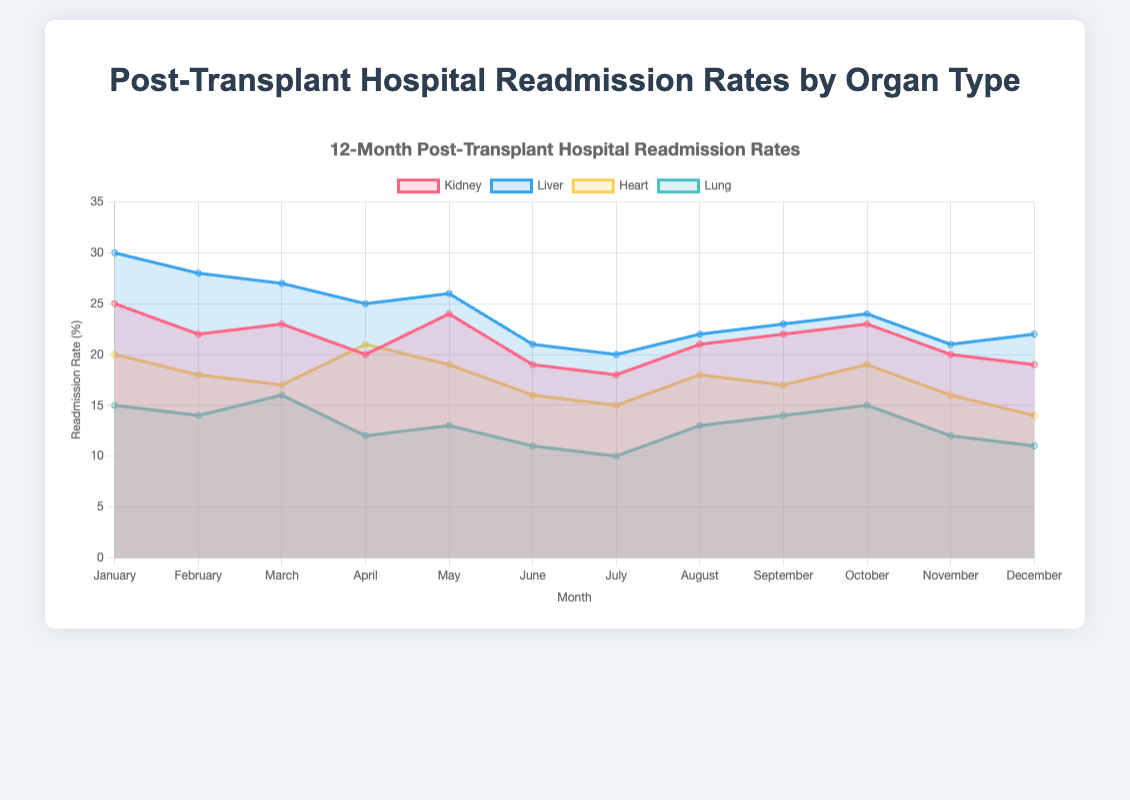How does the readmission rate for kidney transplants change from January to December? Notice that the readmission rate for kidney transplants starts at 25% in January and ends at 19% in December. The rate fluctuates within these months but has an overall decreasing trend.
Answer: Decreases Which organ type has the highest readmission rate in April? Look at the values for each organ type in April. Kidney has 20%, liver has 25%, heart has 21%, and lung has 12%. The liver has the highest readmission rate in April.
Answer: Liver What is the average readmission rate for lungs over the 12 months? Sum the readmission rates for lungs across all months: 15 + 14 + 16 + 12 + 13 + 11 + 10 + 13 + 14 + 15 + 12 + 11 = 156. Divide this by 12 to find the average: 156 / 12 = 13
Answer: 13 Compare the readmission rates for liver and heart transplants in June. Which one is higher? In June, liver transplants have a readmission rate of 21%, and heart transplants have a readmission rate of 16%. Thus, the liver readmission rate is higher.
Answer: Liver In which month is the readmission rate for heart transplants the lowest, and what is that rate? Review the heart transplant readmission rates across all months: January (20), February (18), March (17), April (21), May (19), June (16), July (15), August (18), September (17), October (19), November (16), and December (14). The lowest rate is in December at 14%.
Answer: December, 14% What is the total number of data points displayed for kidney transplants? A year's worth of monthly data is provided for kidney transplants. Therefore, there are 12 data points, one for each month.
Answer: 12 Between which months does the readmission rate for liver transplants show the largest increase? Observe the liver readmission rates for all months and identify the largest month-over-month increase. The largest increase occurs from June (21%) to July (20%), with an increase of 1%.
Answer: June to July How do the readmission rates for lung transplants in January compare to those in July? The readmission rate for lung transplants in January is 15%, while in July it is 10%. There is a decrease when comparing January to July.
Answer: Decrease What's the combined readmission rate for liver and kidney transplants in March? Add the readmission rates for liver and kidney in March: liver (27%) + kidney (23%) = 50%.
Answer: 50% What is the month-over-month change in readmission rate for heart transplants from October to November? The readmission rate for heart transplants in October is 19%, and in November it is 16%. The change is calculated as 16% - 19% = -3%.
Answer: -3% 